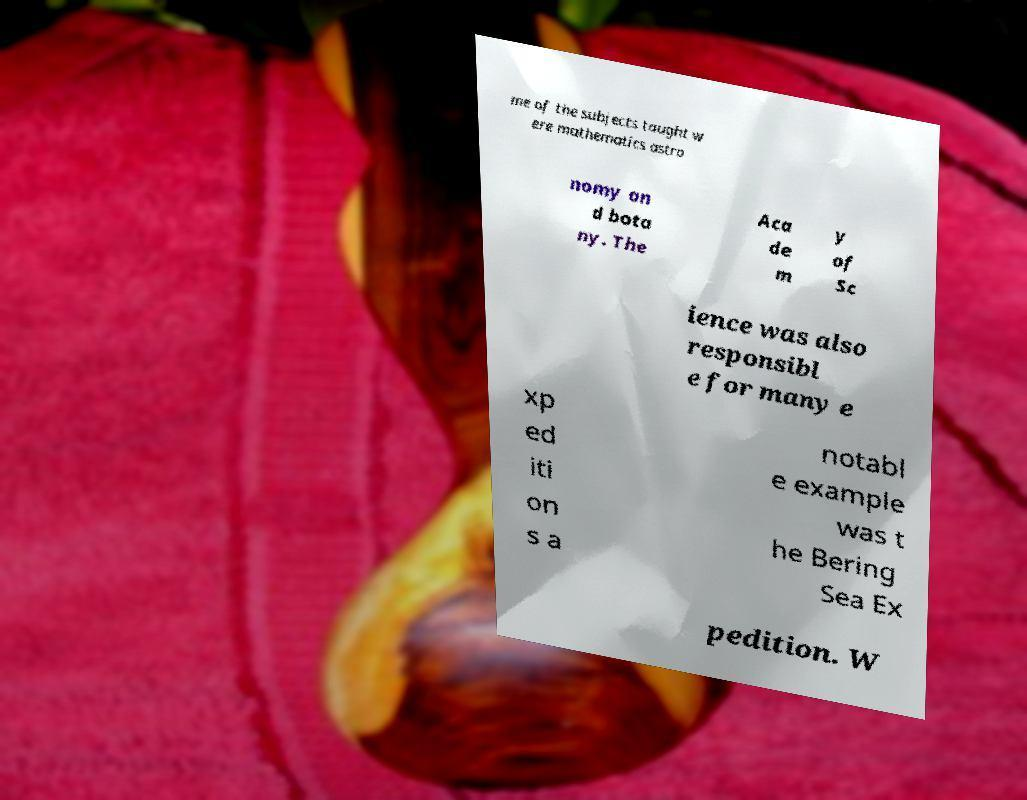Could you extract and type out the text from this image? me of the subjects taught w ere mathematics astro nomy an d bota ny. The Aca de m y of Sc ience was also responsibl e for many e xp ed iti on s a notabl e example was t he Bering Sea Ex pedition. W 